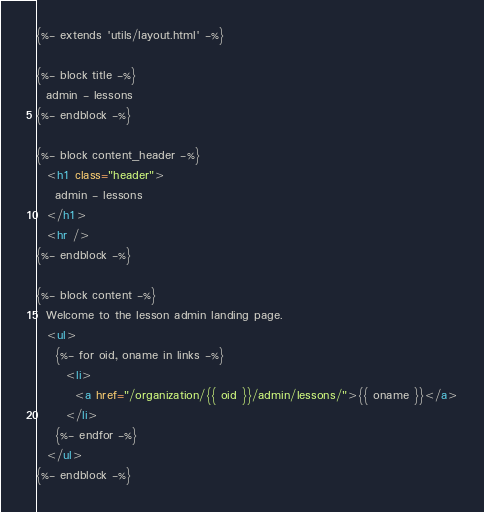Convert code to text. <code><loc_0><loc_0><loc_500><loc_500><_HTML_>{%- extends 'utils/layout.html' -%}

{%- block title -%}
  admin - lessons
{%- endblock -%}

{%- block content_header -%}
  <h1 class="header">
    admin - lessons
  </h1>
  <hr />
{%- endblock -%}

{%- block content -%}
  Welcome to the lesson admin landing page.
  <ul>
    {%- for oid, oname in links -%}
      <li>
        <a href="/organization/{{ oid }}/admin/lessons/">{{ oname }}</a>
      </li>
    {%- endfor -%}
  </ul>
{%- endblock -%}</code> 